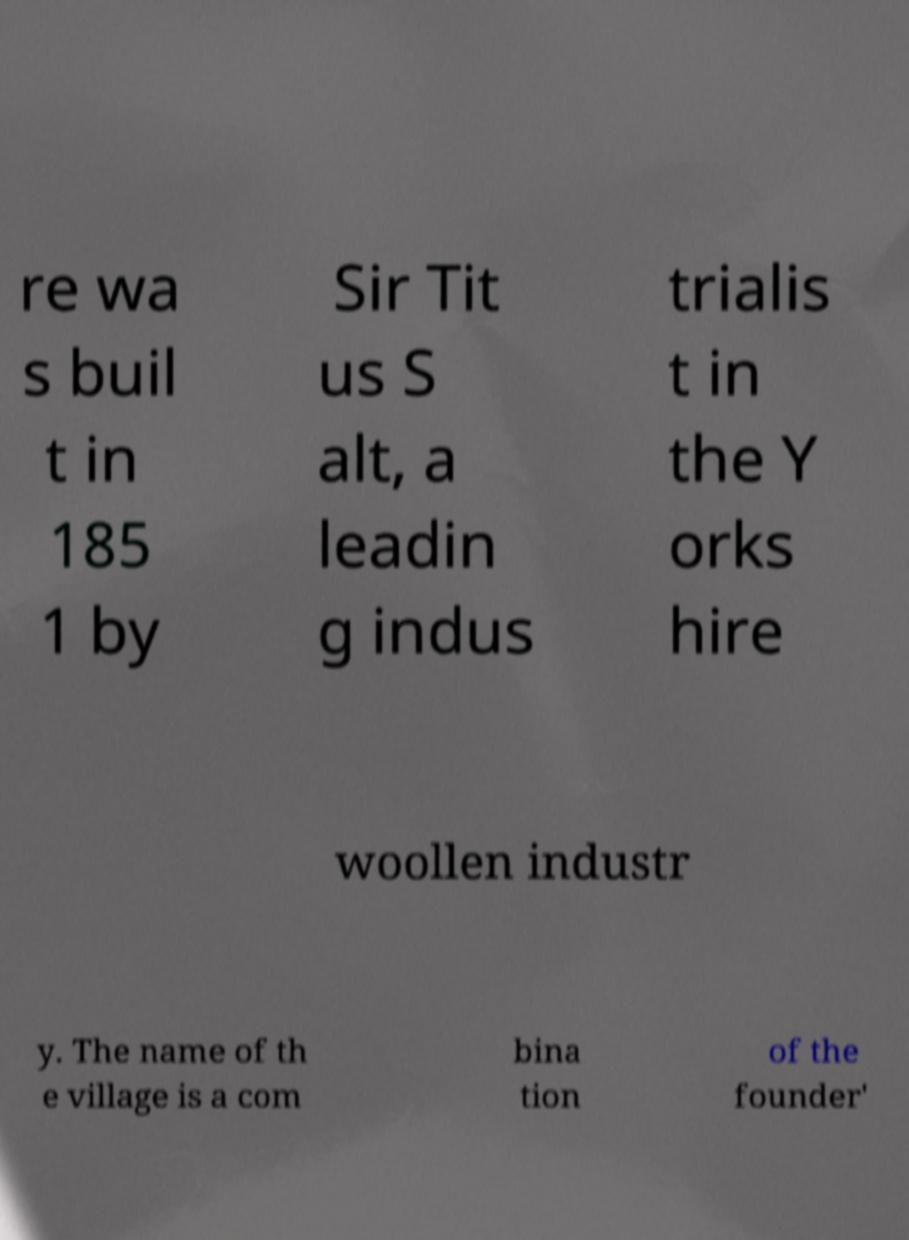Could you assist in decoding the text presented in this image and type it out clearly? re wa s buil t in 185 1 by Sir Tit us S alt, a leadin g indus trialis t in the Y orks hire woollen industr y. The name of th e village is a com bina tion of the founder' 